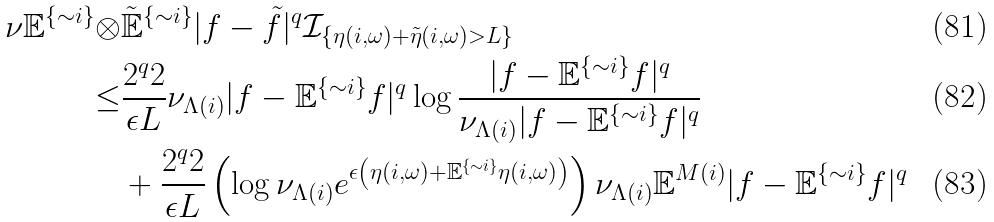Convert formula to latex. <formula><loc_0><loc_0><loc_500><loc_500>\nu \mathbb { E } ^ { \{ \sim i \} } \otimes & \mathbb { \tilde { E } } ^ { \{ \sim i \} } | f - \tilde { f } | ^ { q } \mathbb { \mathcal { I } } _ { \{ \eta ( i , \omega ) + \tilde { \eta } ( i , \omega ) > L \} } \\ \leq & \frac { 2 ^ { q } 2 } { \epsilon L } \nu _ { \Lambda ( i ) } | f - \mathbb { E } ^ { \{ \sim i \} } f | ^ { q } \log \frac { | f - \mathbb { E } ^ { \{ \sim i \} } f | ^ { q } } { \nu _ { \Lambda ( i ) } | f - \mathbb { E } ^ { \{ \sim i \} } f | ^ { q } } \\ & + \frac { 2 ^ { q } 2 } { \epsilon L } \left ( \log \nu _ { \Lambda ( i ) } e ^ { \epsilon \left ( \eta ( i , \omega ) + \mathbb { E } ^ { \{ \sim i \} } \eta ( i , \omega ) \right ) } \right ) \nu _ { \Lambda ( i ) } \mathbb { E } ^ { M ( i ) } | f - \mathbb { E } ^ { \{ \sim i \} } f | ^ { q }</formula> 